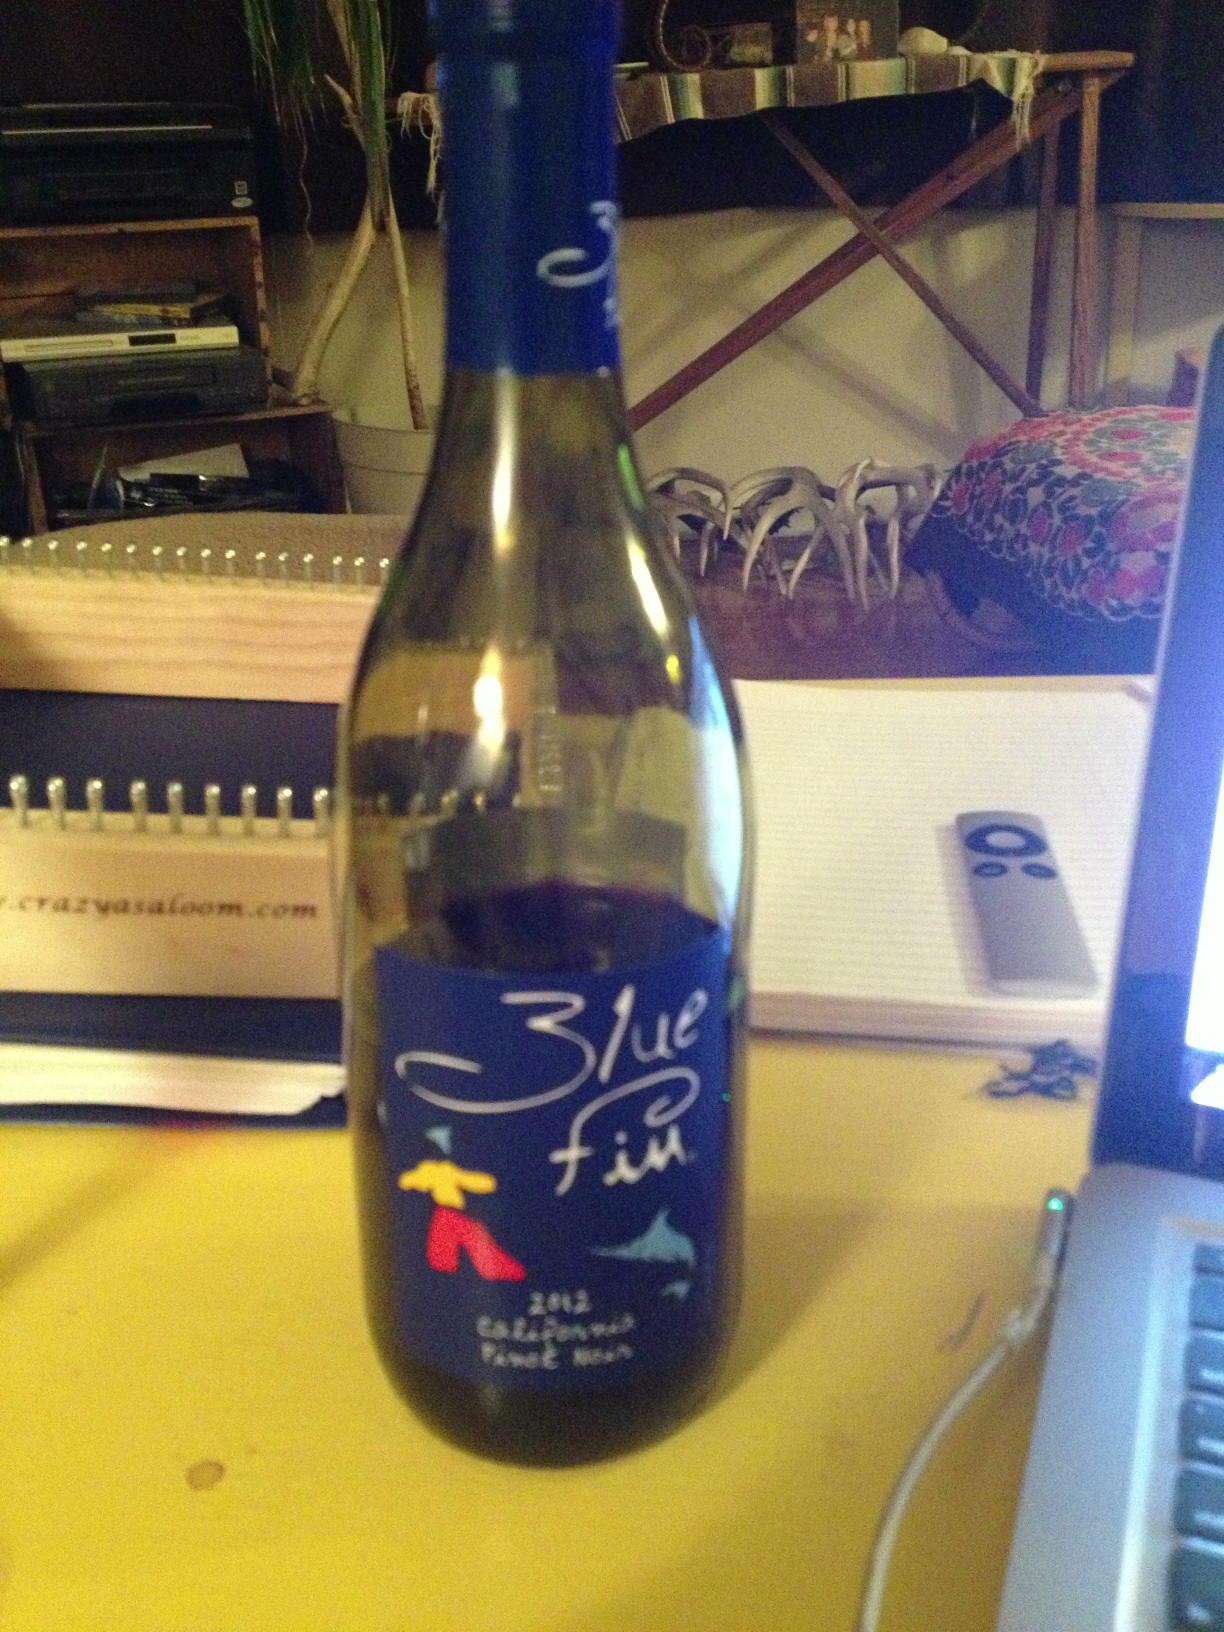Can you tell me more about the type of wine shown? The wine in the image is a 2012 California Pinot Noir, known for its smooth texture and versatile flavor profile that pairs well with a variety of foods. 